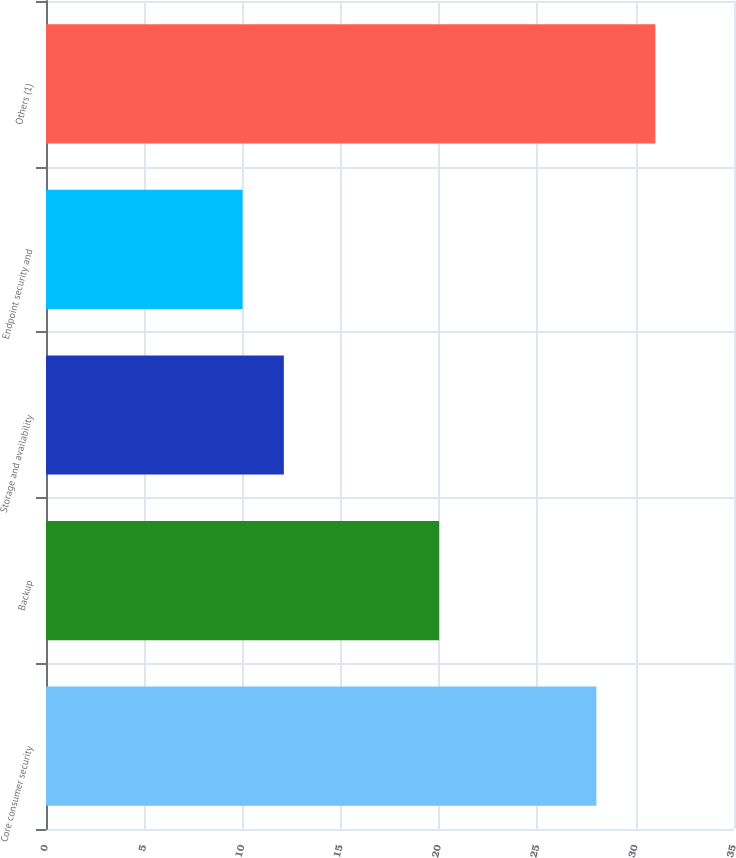Convert chart to OTSL. <chart><loc_0><loc_0><loc_500><loc_500><bar_chart><fcel>Core consumer security<fcel>Backup<fcel>Storage and availability<fcel>Endpoint security and<fcel>Others (1)<nl><fcel>28<fcel>20<fcel>12.1<fcel>10<fcel>31<nl></chart> 